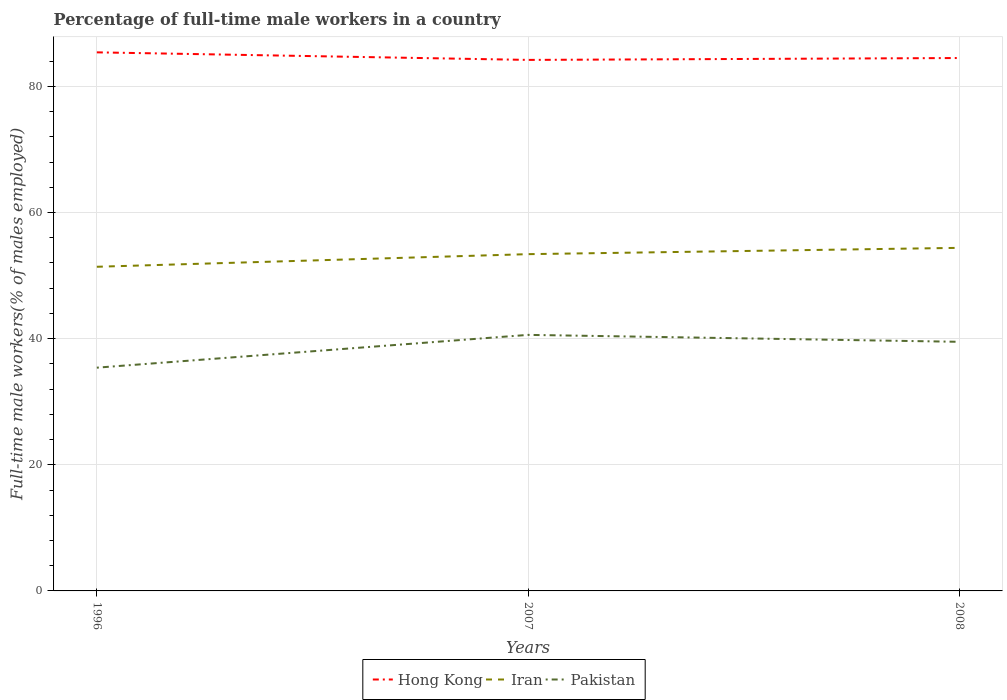How many different coloured lines are there?
Your response must be concise. 3. Across all years, what is the maximum percentage of full-time male workers in Pakistan?
Give a very brief answer. 35.4. What is the total percentage of full-time male workers in Iran in the graph?
Give a very brief answer. -1. What is the difference between the highest and the second highest percentage of full-time male workers in Pakistan?
Make the answer very short. 5.2. What is the difference between the highest and the lowest percentage of full-time male workers in Pakistan?
Your answer should be compact. 2. How many lines are there?
Your answer should be compact. 3. How many years are there in the graph?
Give a very brief answer. 3. What is the difference between two consecutive major ticks on the Y-axis?
Give a very brief answer. 20. Does the graph contain any zero values?
Make the answer very short. No. How are the legend labels stacked?
Provide a succinct answer. Horizontal. What is the title of the graph?
Make the answer very short. Percentage of full-time male workers in a country. What is the label or title of the X-axis?
Keep it short and to the point. Years. What is the label or title of the Y-axis?
Keep it short and to the point. Full-time male workers(% of males employed). What is the Full-time male workers(% of males employed) in Hong Kong in 1996?
Give a very brief answer. 85.4. What is the Full-time male workers(% of males employed) of Iran in 1996?
Make the answer very short. 51.4. What is the Full-time male workers(% of males employed) in Pakistan in 1996?
Your answer should be compact. 35.4. What is the Full-time male workers(% of males employed) in Hong Kong in 2007?
Ensure brevity in your answer.  84.2. What is the Full-time male workers(% of males employed) of Iran in 2007?
Provide a succinct answer. 53.4. What is the Full-time male workers(% of males employed) in Pakistan in 2007?
Provide a succinct answer. 40.6. What is the Full-time male workers(% of males employed) of Hong Kong in 2008?
Ensure brevity in your answer.  84.5. What is the Full-time male workers(% of males employed) in Iran in 2008?
Keep it short and to the point. 54.4. What is the Full-time male workers(% of males employed) of Pakistan in 2008?
Offer a terse response. 39.5. Across all years, what is the maximum Full-time male workers(% of males employed) of Hong Kong?
Give a very brief answer. 85.4. Across all years, what is the maximum Full-time male workers(% of males employed) of Iran?
Give a very brief answer. 54.4. Across all years, what is the maximum Full-time male workers(% of males employed) of Pakistan?
Provide a succinct answer. 40.6. Across all years, what is the minimum Full-time male workers(% of males employed) of Hong Kong?
Keep it short and to the point. 84.2. Across all years, what is the minimum Full-time male workers(% of males employed) in Iran?
Make the answer very short. 51.4. Across all years, what is the minimum Full-time male workers(% of males employed) of Pakistan?
Ensure brevity in your answer.  35.4. What is the total Full-time male workers(% of males employed) in Hong Kong in the graph?
Provide a short and direct response. 254.1. What is the total Full-time male workers(% of males employed) of Iran in the graph?
Your answer should be very brief. 159.2. What is the total Full-time male workers(% of males employed) of Pakistan in the graph?
Offer a terse response. 115.5. What is the difference between the Full-time male workers(% of males employed) in Hong Kong in 1996 and that in 2007?
Provide a succinct answer. 1.2. What is the difference between the Full-time male workers(% of males employed) of Pakistan in 1996 and that in 2007?
Offer a very short reply. -5.2. What is the difference between the Full-time male workers(% of males employed) in Pakistan in 1996 and that in 2008?
Your answer should be compact. -4.1. What is the difference between the Full-time male workers(% of males employed) in Hong Kong in 2007 and that in 2008?
Your answer should be very brief. -0.3. What is the difference between the Full-time male workers(% of males employed) of Hong Kong in 1996 and the Full-time male workers(% of males employed) of Pakistan in 2007?
Your answer should be compact. 44.8. What is the difference between the Full-time male workers(% of males employed) of Iran in 1996 and the Full-time male workers(% of males employed) of Pakistan in 2007?
Keep it short and to the point. 10.8. What is the difference between the Full-time male workers(% of males employed) in Hong Kong in 1996 and the Full-time male workers(% of males employed) in Iran in 2008?
Ensure brevity in your answer.  31. What is the difference between the Full-time male workers(% of males employed) of Hong Kong in 1996 and the Full-time male workers(% of males employed) of Pakistan in 2008?
Offer a terse response. 45.9. What is the difference between the Full-time male workers(% of males employed) in Hong Kong in 2007 and the Full-time male workers(% of males employed) in Iran in 2008?
Make the answer very short. 29.8. What is the difference between the Full-time male workers(% of males employed) of Hong Kong in 2007 and the Full-time male workers(% of males employed) of Pakistan in 2008?
Keep it short and to the point. 44.7. What is the difference between the Full-time male workers(% of males employed) in Iran in 2007 and the Full-time male workers(% of males employed) in Pakistan in 2008?
Your response must be concise. 13.9. What is the average Full-time male workers(% of males employed) in Hong Kong per year?
Provide a short and direct response. 84.7. What is the average Full-time male workers(% of males employed) in Iran per year?
Give a very brief answer. 53.07. What is the average Full-time male workers(% of males employed) in Pakistan per year?
Your answer should be very brief. 38.5. In the year 1996, what is the difference between the Full-time male workers(% of males employed) of Hong Kong and Full-time male workers(% of males employed) of Pakistan?
Keep it short and to the point. 50. In the year 1996, what is the difference between the Full-time male workers(% of males employed) in Iran and Full-time male workers(% of males employed) in Pakistan?
Your answer should be very brief. 16. In the year 2007, what is the difference between the Full-time male workers(% of males employed) in Hong Kong and Full-time male workers(% of males employed) in Iran?
Ensure brevity in your answer.  30.8. In the year 2007, what is the difference between the Full-time male workers(% of males employed) in Hong Kong and Full-time male workers(% of males employed) in Pakistan?
Ensure brevity in your answer.  43.6. In the year 2007, what is the difference between the Full-time male workers(% of males employed) of Iran and Full-time male workers(% of males employed) of Pakistan?
Provide a short and direct response. 12.8. In the year 2008, what is the difference between the Full-time male workers(% of males employed) of Hong Kong and Full-time male workers(% of males employed) of Iran?
Offer a terse response. 30.1. In the year 2008, what is the difference between the Full-time male workers(% of males employed) in Hong Kong and Full-time male workers(% of males employed) in Pakistan?
Your response must be concise. 45. What is the ratio of the Full-time male workers(% of males employed) of Hong Kong in 1996 to that in 2007?
Give a very brief answer. 1.01. What is the ratio of the Full-time male workers(% of males employed) in Iran in 1996 to that in 2007?
Offer a terse response. 0.96. What is the ratio of the Full-time male workers(% of males employed) of Pakistan in 1996 to that in 2007?
Provide a short and direct response. 0.87. What is the ratio of the Full-time male workers(% of males employed) in Hong Kong in 1996 to that in 2008?
Provide a short and direct response. 1.01. What is the ratio of the Full-time male workers(% of males employed) in Iran in 1996 to that in 2008?
Make the answer very short. 0.94. What is the ratio of the Full-time male workers(% of males employed) in Pakistan in 1996 to that in 2008?
Keep it short and to the point. 0.9. What is the ratio of the Full-time male workers(% of males employed) of Hong Kong in 2007 to that in 2008?
Ensure brevity in your answer.  1. What is the ratio of the Full-time male workers(% of males employed) of Iran in 2007 to that in 2008?
Offer a very short reply. 0.98. What is the ratio of the Full-time male workers(% of males employed) in Pakistan in 2007 to that in 2008?
Keep it short and to the point. 1.03. What is the difference between the highest and the second highest Full-time male workers(% of males employed) of Pakistan?
Offer a very short reply. 1.1. What is the difference between the highest and the lowest Full-time male workers(% of males employed) in Iran?
Your response must be concise. 3. 